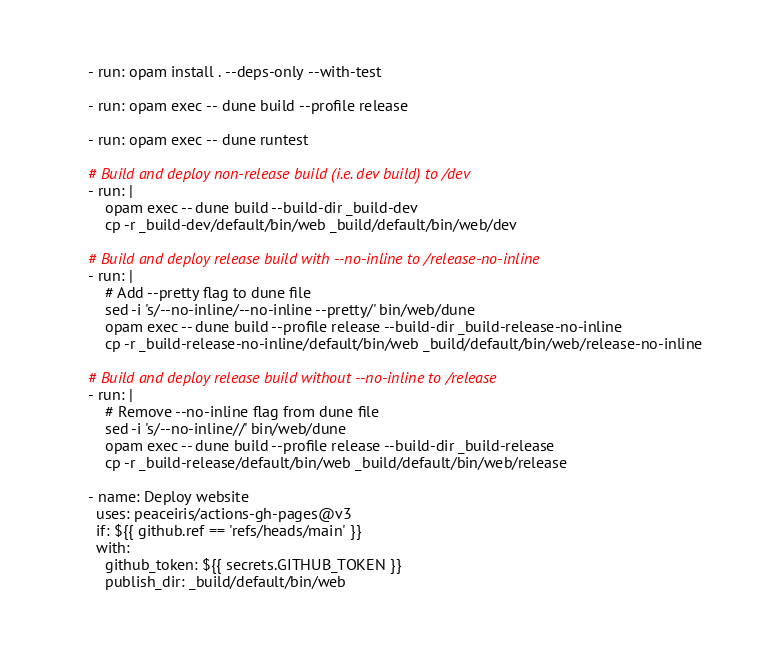Convert code to text. <code><loc_0><loc_0><loc_500><loc_500><_YAML_>      - run: opam install . --deps-only --with-test

      - run: opam exec -- dune build --profile release

      - run: opam exec -- dune runtest

      # Build and deploy non-release build (i.e. dev build) to /dev
      - run: |
          opam exec -- dune build --build-dir _build-dev
          cp -r _build-dev/default/bin/web _build/default/bin/web/dev

      # Build and deploy release build with --no-inline to /release-no-inline
      - run: |
          # Add --pretty flag to dune file
          sed -i 's/--no-inline/--no-inline --pretty/' bin/web/dune
          opam exec -- dune build --profile release --build-dir _build-release-no-inline
          cp -r _build-release-no-inline/default/bin/web _build/default/bin/web/release-no-inline

      # Build and deploy release build without --no-inline to /release
      - run: |
          # Remove --no-inline flag from dune file
          sed -i 's/--no-inline//' bin/web/dune
          opam exec -- dune build --profile release --build-dir _build-release
          cp -r _build-release/default/bin/web _build/default/bin/web/release

      - name: Deploy website
        uses: peaceiris/actions-gh-pages@v3
        if: ${{ github.ref == 'refs/heads/main' }}
        with:
          github_token: ${{ secrets.GITHUB_TOKEN }}
          publish_dir: _build/default/bin/web
</code> 